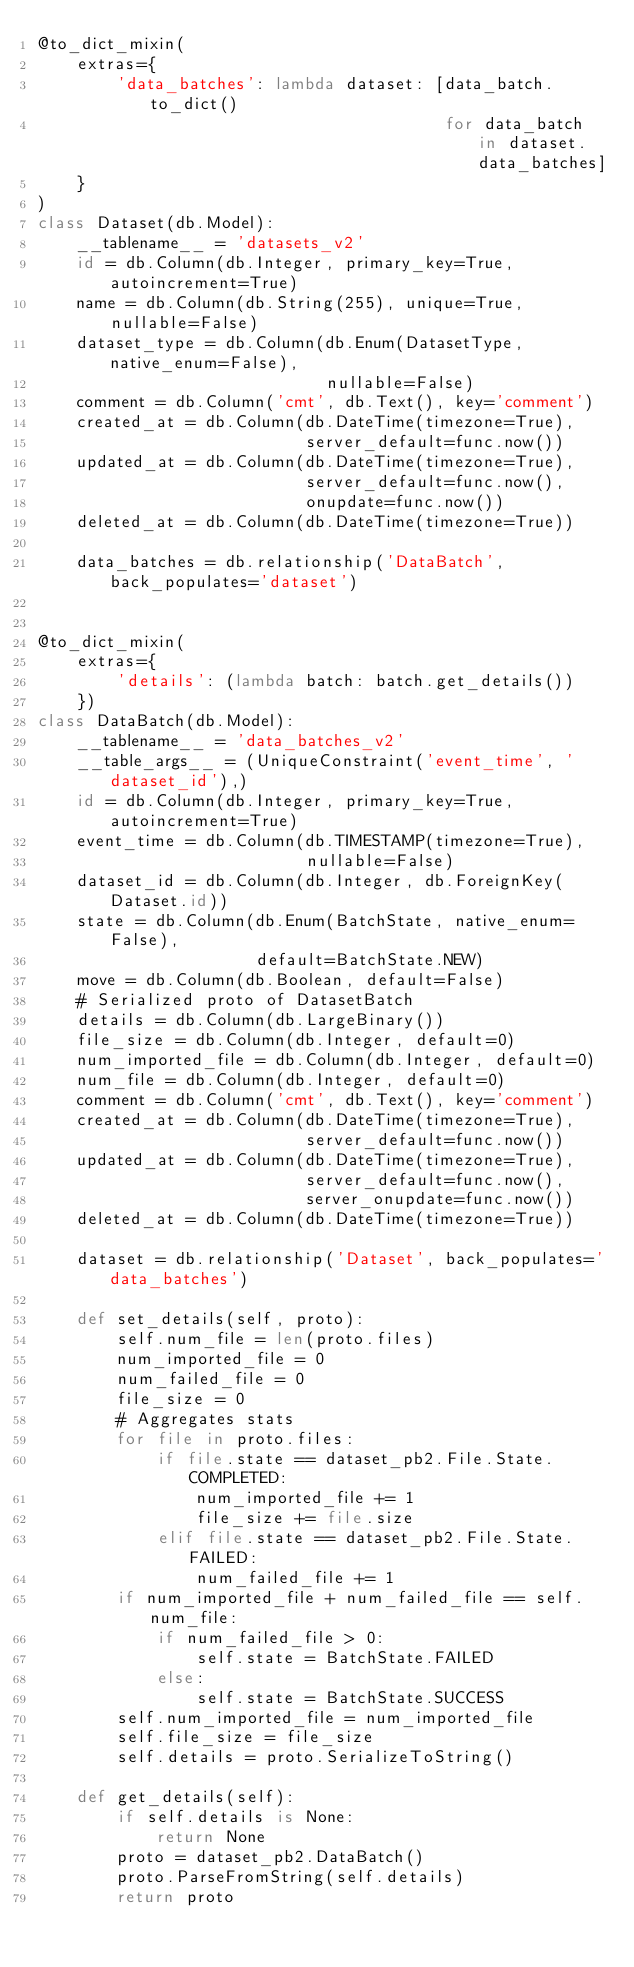Convert code to text. <code><loc_0><loc_0><loc_500><loc_500><_Python_>@to_dict_mixin(
    extras={
        'data_batches': lambda dataset: [data_batch.to_dict()
                                         for data_batch in dataset.data_batches]
    }
)
class Dataset(db.Model):
    __tablename__ = 'datasets_v2'
    id = db.Column(db.Integer, primary_key=True, autoincrement=True)
    name = db.Column(db.String(255), unique=True, nullable=False)
    dataset_type = db.Column(db.Enum(DatasetType, native_enum=False),
                             nullable=False)
    comment = db.Column('cmt', db.Text(), key='comment')
    created_at = db.Column(db.DateTime(timezone=True),
                           server_default=func.now())
    updated_at = db.Column(db.DateTime(timezone=True),
                           server_default=func.now(),
                           onupdate=func.now())
    deleted_at = db.Column(db.DateTime(timezone=True))

    data_batches = db.relationship('DataBatch', back_populates='dataset')


@to_dict_mixin(
    extras={
        'details': (lambda batch: batch.get_details())
    })
class DataBatch(db.Model):
    __tablename__ = 'data_batches_v2'
    __table_args__ = (UniqueConstraint('event_time', 'dataset_id'),)
    id = db.Column(db.Integer, primary_key=True, autoincrement=True)
    event_time = db.Column(db.TIMESTAMP(timezone=True),
                           nullable=False)
    dataset_id = db.Column(db.Integer, db.ForeignKey(Dataset.id))
    state = db.Column(db.Enum(BatchState, native_enum=False),
                      default=BatchState.NEW)
    move = db.Column(db.Boolean, default=False)
    # Serialized proto of DatasetBatch
    details = db.Column(db.LargeBinary())
    file_size = db.Column(db.Integer, default=0)
    num_imported_file = db.Column(db.Integer, default=0)
    num_file = db.Column(db.Integer, default=0)
    comment = db.Column('cmt', db.Text(), key='comment')
    created_at = db.Column(db.DateTime(timezone=True),
                           server_default=func.now())
    updated_at = db.Column(db.DateTime(timezone=True),
                           server_default=func.now(),
                           server_onupdate=func.now())
    deleted_at = db.Column(db.DateTime(timezone=True))

    dataset = db.relationship('Dataset', back_populates='data_batches')

    def set_details(self, proto):
        self.num_file = len(proto.files)
        num_imported_file = 0
        num_failed_file = 0
        file_size = 0
        # Aggregates stats
        for file in proto.files:
            if file.state == dataset_pb2.File.State.COMPLETED:
                num_imported_file += 1
                file_size += file.size
            elif file.state == dataset_pb2.File.State.FAILED:
                num_failed_file += 1
        if num_imported_file + num_failed_file == self.num_file:
            if num_failed_file > 0:
                self.state = BatchState.FAILED
            else:
                self.state = BatchState.SUCCESS
        self.num_imported_file = num_imported_file
        self.file_size = file_size
        self.details = proto.SerializeToString()

    def get_details(self):
        if self.details is None:
            return None
        proto = dataset_pb2.DataBatch()
        proto.ParseFromString(self.details)
        return proto
</code> 